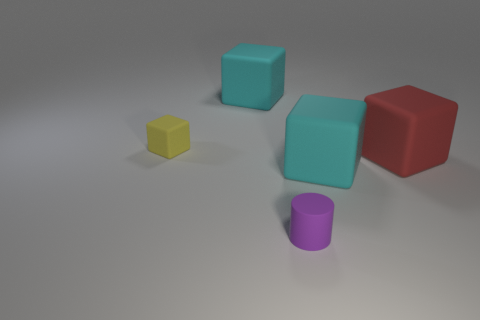Is there any other thing that has the same shape as the tiny purple rubber object?
Your answer should be compact. No. Are any cyan blocks visible?
Provide a short and direct response. Yes. Do the red thing and the tiny purple matte object have the same shape?
Make the answer very short. No. How many small objects are red shiny things or yellow cubes?
Make the answer very short. 1. The tiny cylinder is what color?
Ensure brevity in your answer.  Purple. What is the shape of the rubber object that is behind the yellow matte thing that is left of the rubber cylinder?
Your answer should be compact. Cube. Is there a large red thing that has the same material as the small purple cylinder?
Ensure brevity in your answer.  Yes. Does the cyan thing that is to the right of the cylinder have the same size as the yellow block?
Provide a succinct answer. No. How many green objects are either small matte blocks or blocks?
Ensure brevity in your answer.  0. There is a purple thing in front of the yellow block; what is it made of?
Offer a terse response. Rubber. 